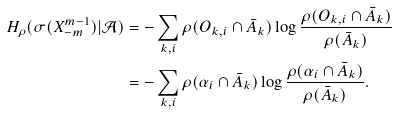Convert formula to latex. <formula><loc_0><loc_0><loc_500><loc_500>H _ { \rho } ( \sigma ( X _ { - m } ^ { m - 1 } ) | \mathcal { A } ) & = - \sum _ { k , i } \rho ( O _ { k , i } \cap \bar { A } _ { k } ) \log \frac { \rho ( O _ { k , i } \cap \bar { A } _ { k } ) } { \rho ( \bar { A } _ { k } ) } \\ & = - \sum _ { k , i } \rho ( \alpha _ { i } \cap \bar { A } _ { k } ) \log \frac { \rho ( \alpha _ { i } \cap \bar { A } _ { k } ) } { \rho ( \bar { A } _ { k } ) } .</formula> 